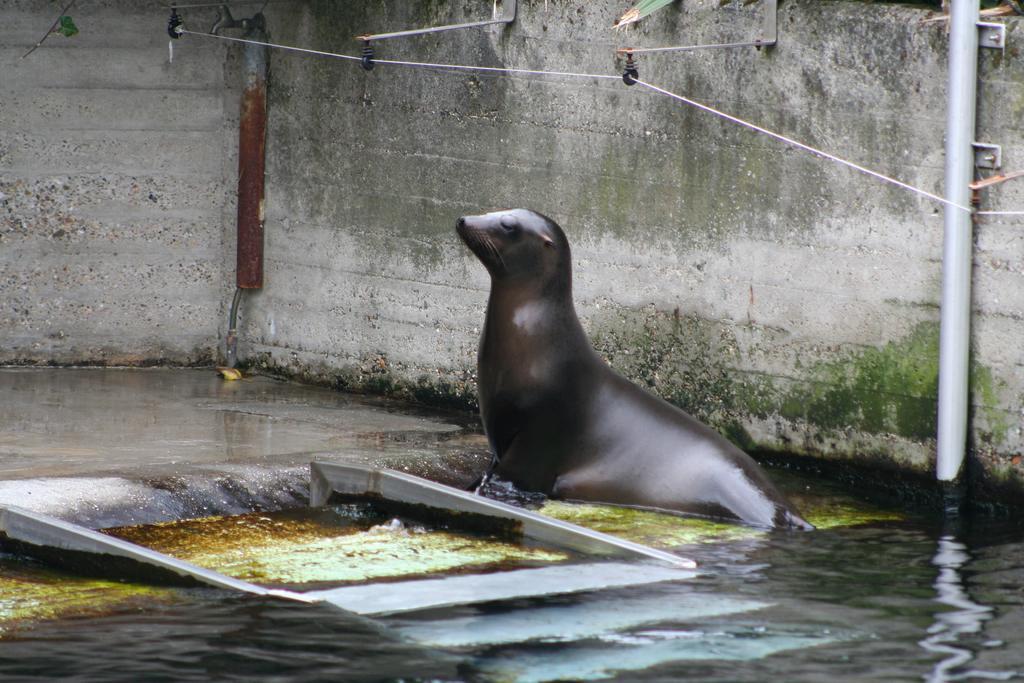Please provide a concise description of this image. In this picture we can see a sea lion in the water, beside to it we can find few pipes and metal rods on the wall. 